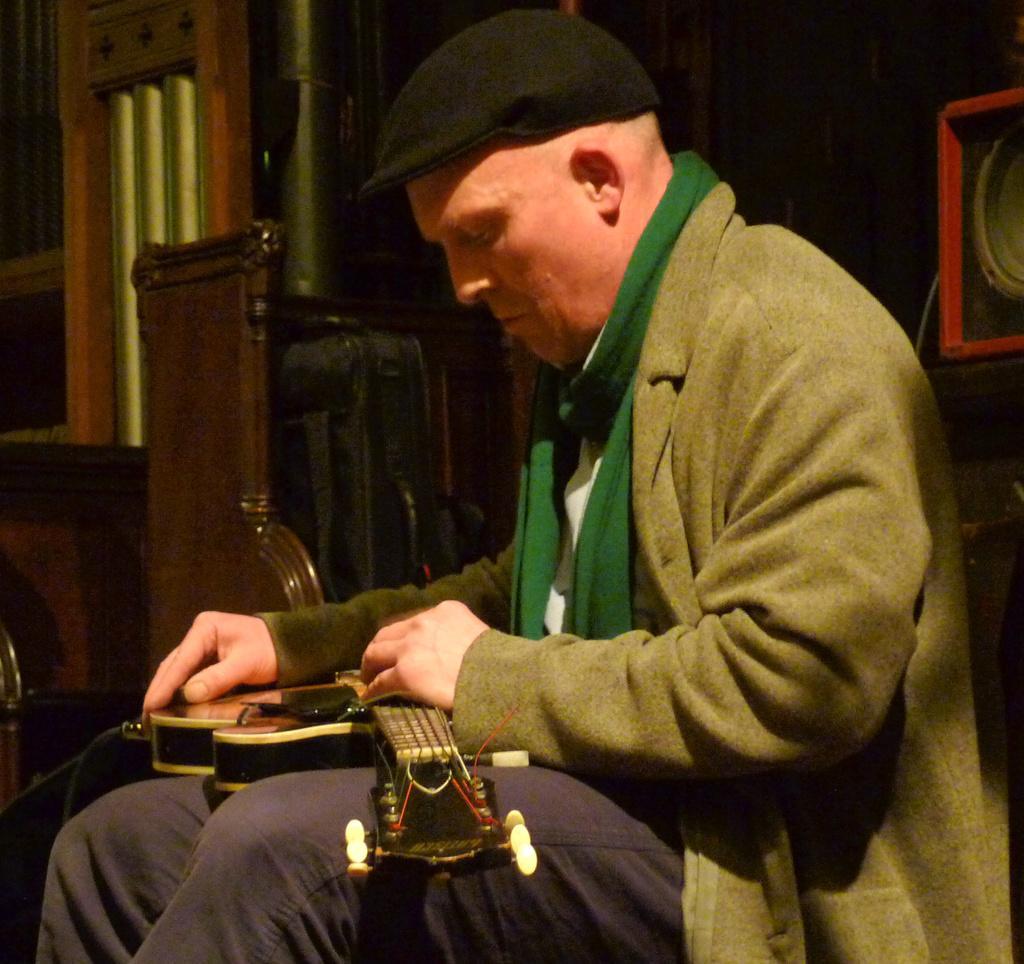Please provide a concise description of this image. In this image we can see there is a person sitting and holding a musical instrument. And at the back there is a red color object and there is a stand, window and a few objects. 